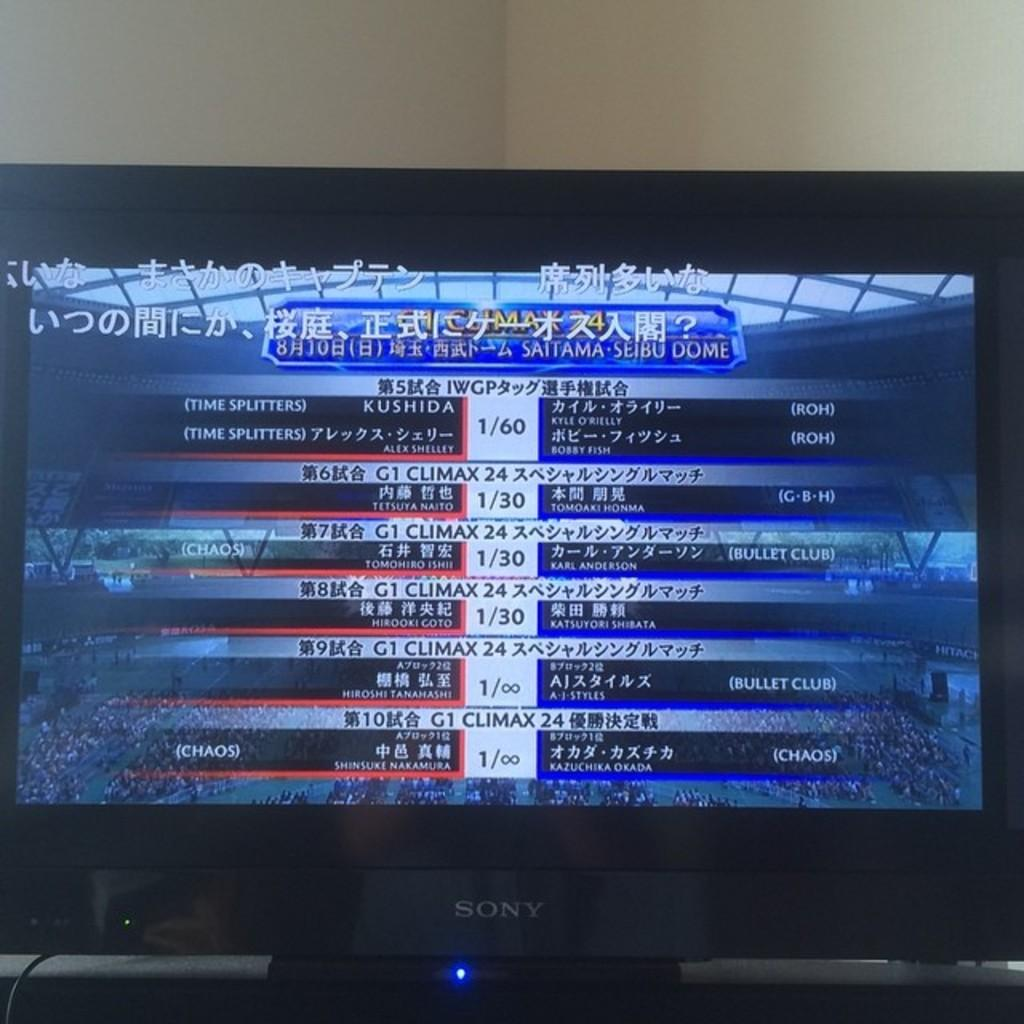<image>
Summarize the visual content of the image. A Sony television screen displays information in Japanese. 